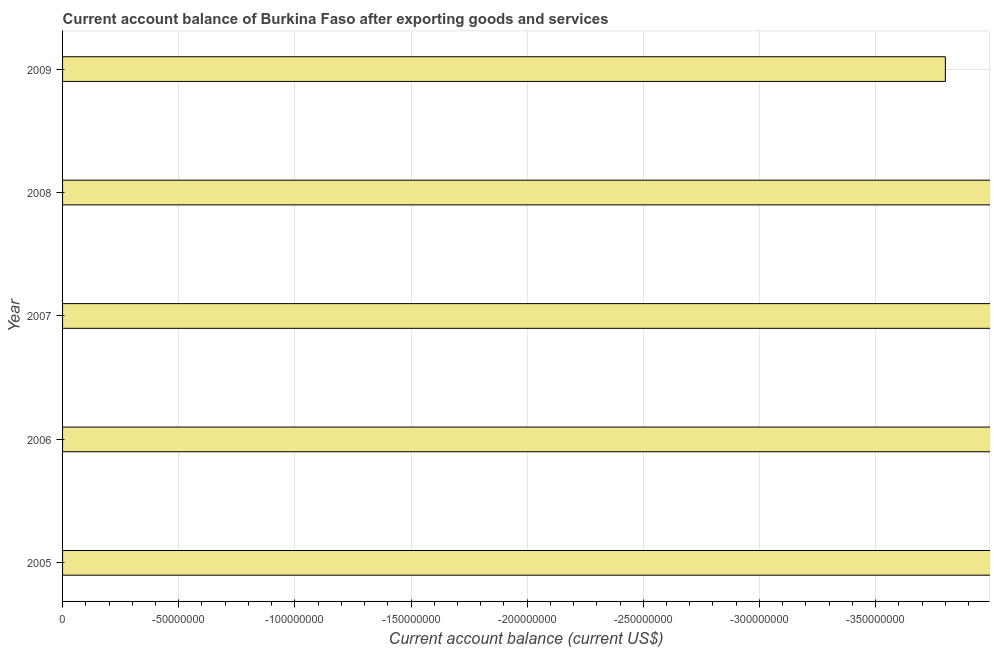Does the graph contain any zero values?
Keep it short and to the point. Yes. Does the graph contain grids?
Your response must be concise. Yes. What is the title of the graph?
Keep it short and to the point. Current account balance of Burkina Faso after exporting goods and services. What is the label or title of the X-axis?
Your response must be concise. Current account balance (current US$). What is the label or title of the Y-axis?
Offer a terse response. Year. Across all years, what is the minimum current account balance?
Keep it short and to the point. 0. What is the sum of the current account balance?
Offer a terse response. 0. What is the average current account balance per year?
Your answer should be compact. 0. In how many years, is the current account balance greater than the average current account balance taken over all years?
Provide a succinct answer. 0. How many bars are there?
Your response must be concise. 0. Are all the bars in the graph horizontal?
Your answer should be compact. Yes. How many years are there in the graph?
Your answer should be compact. 5. What is the difference between two consecutive major ticks on the X-axis?
Ensure brevity in your answer.  5.00e+07. What is the Current account balance (current US$) in 2007?
Keep it short and to the point. 0. What is the Current account balance (current US$) in 2009?
Provide a succinct answer. 0. 